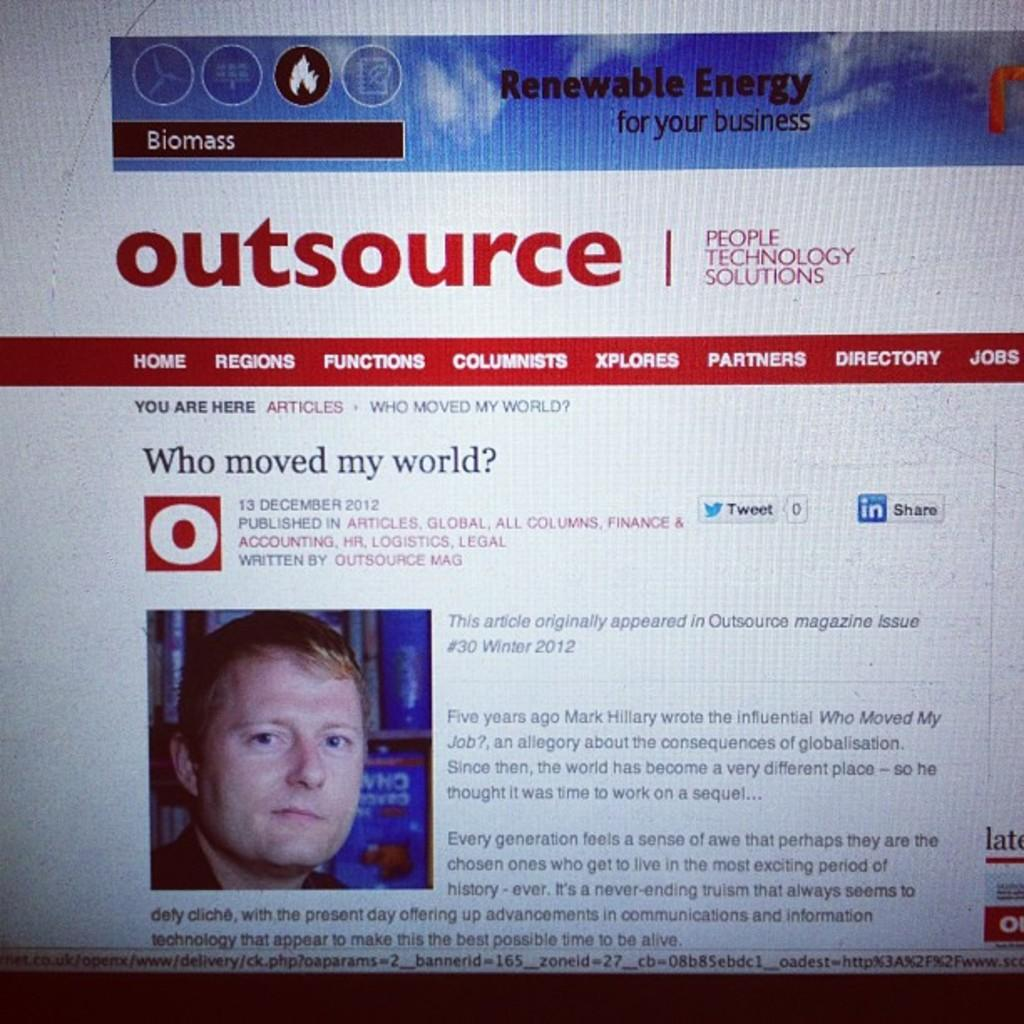What is the main object in the image? There is a screen in the image. What can be seen on the screen? There is text present on the screen, and there is a photograph of a person on the screen. What type of garden can be seen in the image? There is no garden present in the image; it features a screen with text and a photograph of a person. What emotion does the needle convey in the image? There is no needle present in the image, so it cannot convey any emotion. 